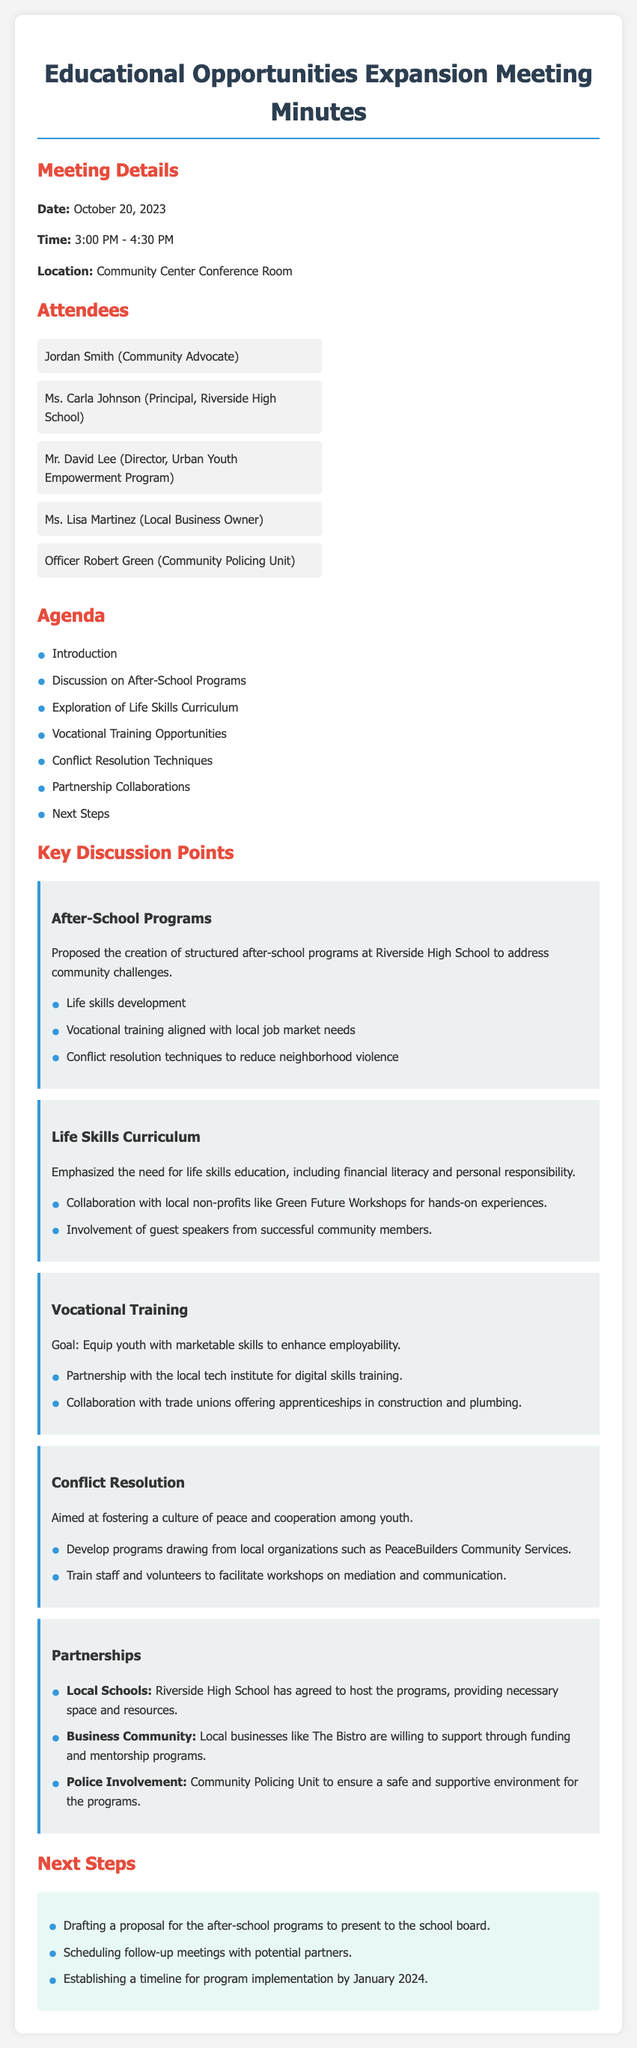What is the date of the meeting? The date of the meeting is clearly stated in the meeting details section of the document.
Answer: October 20, 2023 Who is the principal of Riverside High School? The principal's name is listed among the attendees of the meeting.
Answer: Ms. Carla Johnson What is the main goal of the vocational training program? The goal is outlined in the key discussion points focusing on vocational training.
Answer: Equip youth with marketable skills What local organization is mentioned for conflict resolution? Specific organizations for conflict resolution are highlighted in the key discussion points.
Answer: PeaceBuilders Community Services How will local businesses support the programs? The way local businesses will support the programs is mentioned in the partnerships section.
Answer: Funding and mentorship programs What is the next step regarding the proposal? The next step concerning the proposal is listed under the next steps section of the document.
Answer: Drafting a proposal for the after-school programs What time did the meeting start? The starting time is included in the meeting details section.
Answer: 3:00 PM Which community advocate is listed as an attendee? The names of attendees include a community advocate mentioned in the attendees section.
Answer: Jordan Smith 